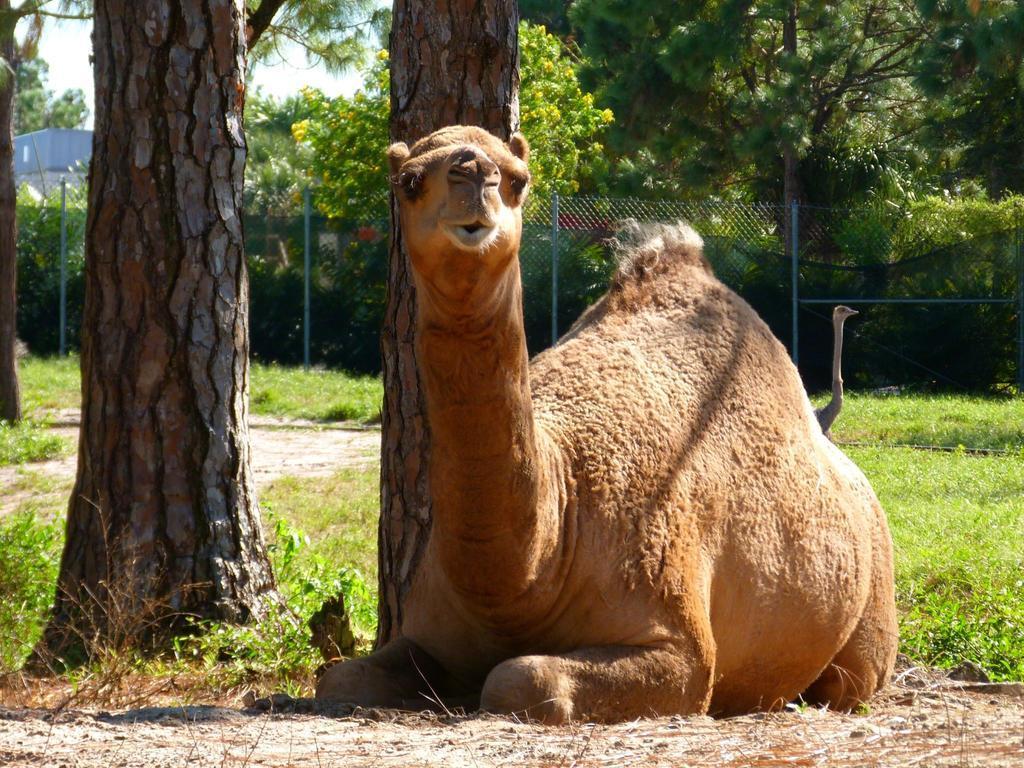Could you give a brief overview of what you see in this image? This picture shows a camel on the ground and we see a bird on the side and we see grass on the ground and few trees and a house and we see a metal fence and a cloudy sky. The camel is brown in color. 